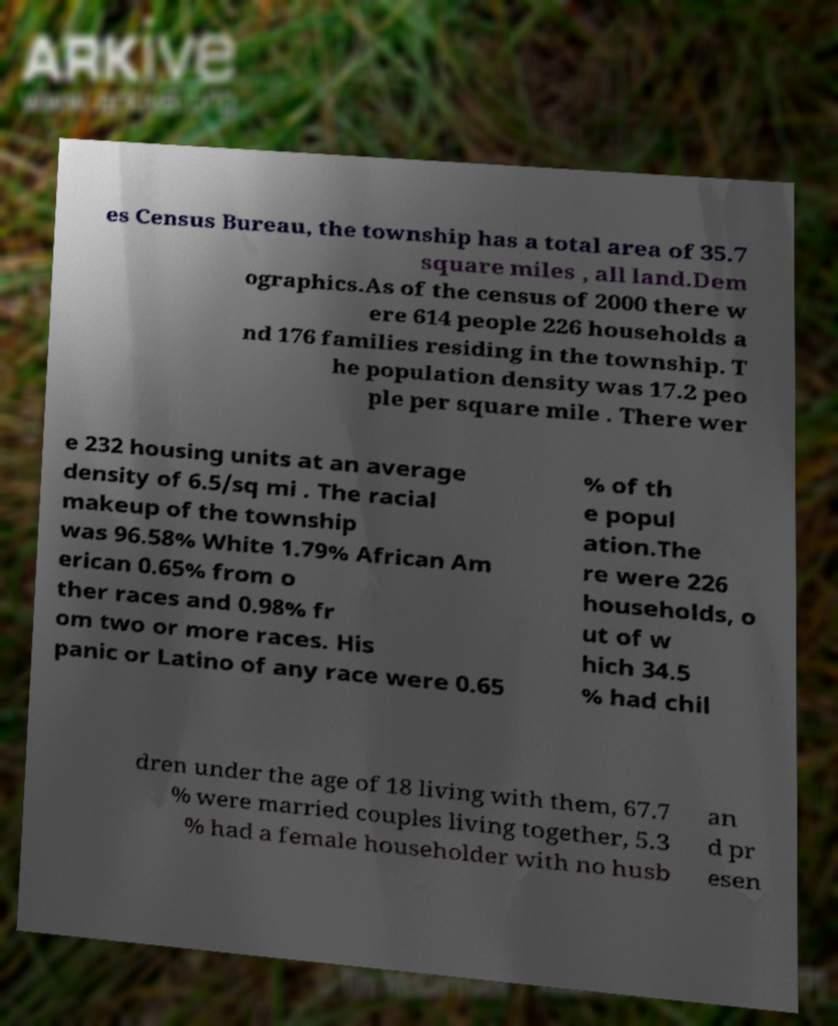I need the written content from this picture converted into text. Can you do that? es Census Bureau, the township has a total area of 35.7 square miles , all land.Dem ographics.As of the census of 2000 there w ere 614 people 226 households a nd 176 families residing in the township. T he population density was 17.2 peo ple per square mile . There wer e 232 housing units at an average density of 6.5/sq mi . The racial makeup of the township was 96.58% White 1.79% African Am erican 0.65% from o ther races and 0.98% fr om two or more races. His panic or Latino of any race were 0.65 % of th e popul ation.The re were 226 households, o ut of w hich 34.5 % had chil dren under the age of 18 living with them, 67.7 % were married couples living together, 5.3 % had a female householder with no husb an d pr esen 